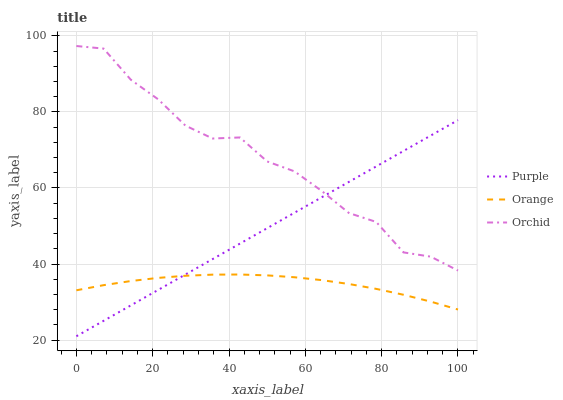Does Orange have the minimum area under the curve?
Answer yes or no. Yes. Does Orchid have the maximum area under the curve?
Answer yes or no. Yes. Does Orchid have the minimum area under the curve?
Answer yes or no. No. Does Orange have the maximum area under the curve?
Answer yes or no. No. Is Purple the smoothest?
Answer yes or no. Yes. Is Orchid the roughest?
Answer yes or no. Yes. Is Orange the smoothest?
Answer yes or no. No. Is Orange the roughest?
Answer yes or no. No. Does Orange have the lowest value?
Answer yes or no. No. Does Orange have the highest value?
Answer yes or no. No. Is Orange less than Orchid?
Answer yes or no. Yes. Is Orchid greater than Orange?
Answer yes or no. Yes. Does Orange intersect Orchid?
Answer yes or no. No. 